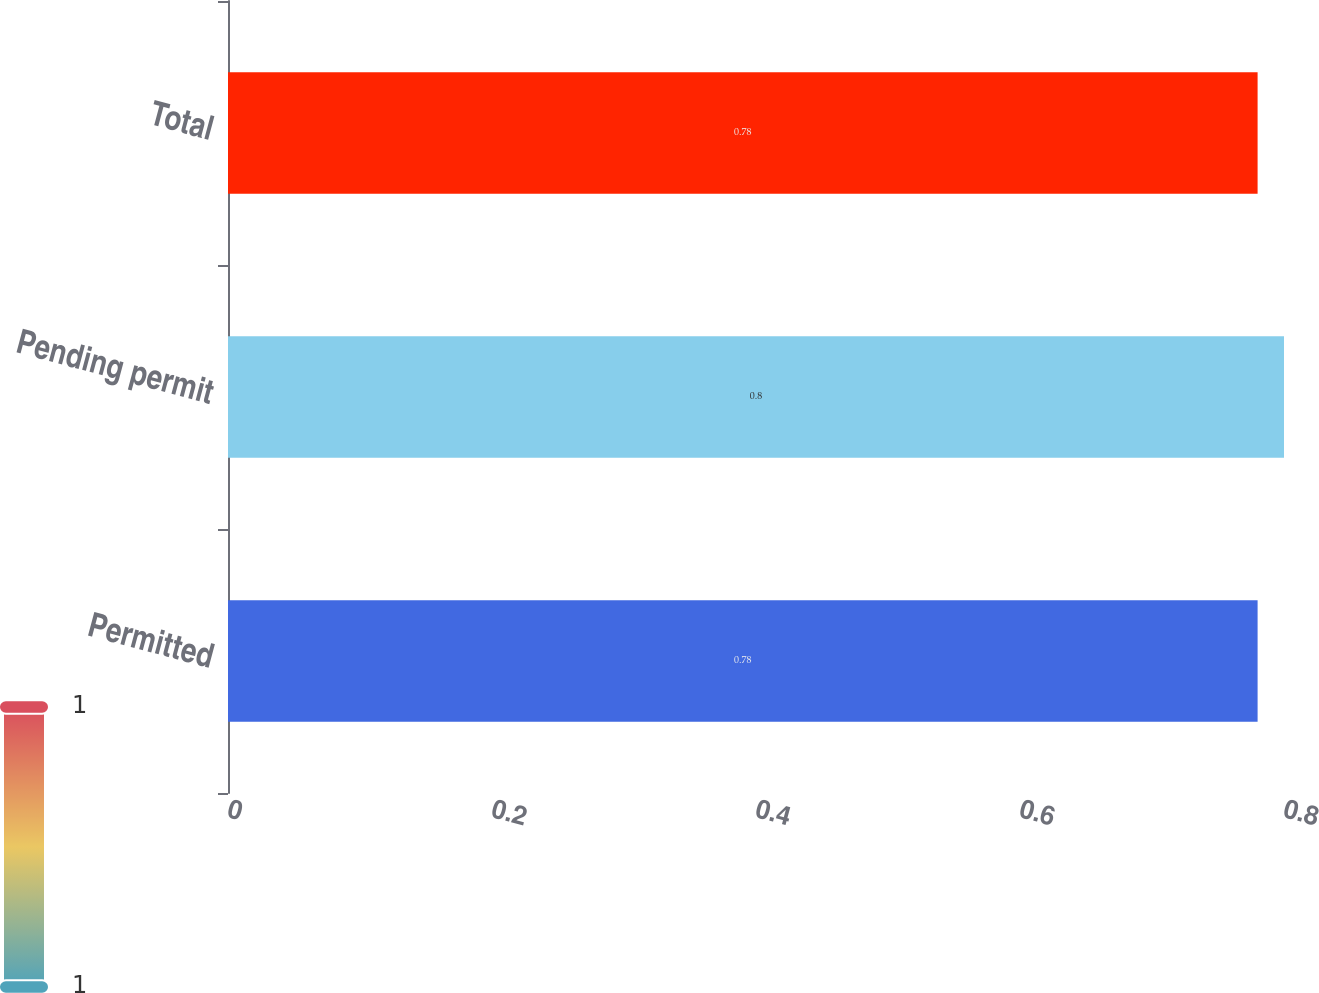Convert chart. <chart><loc_0><loc_0><loc_500><loc_500><bar_chart><fcel>Permitted<fcel>Pending permit<fcel>Total<nl><fcel>0.78<fcel>0.8<fcel>0.78<nl></chart> 